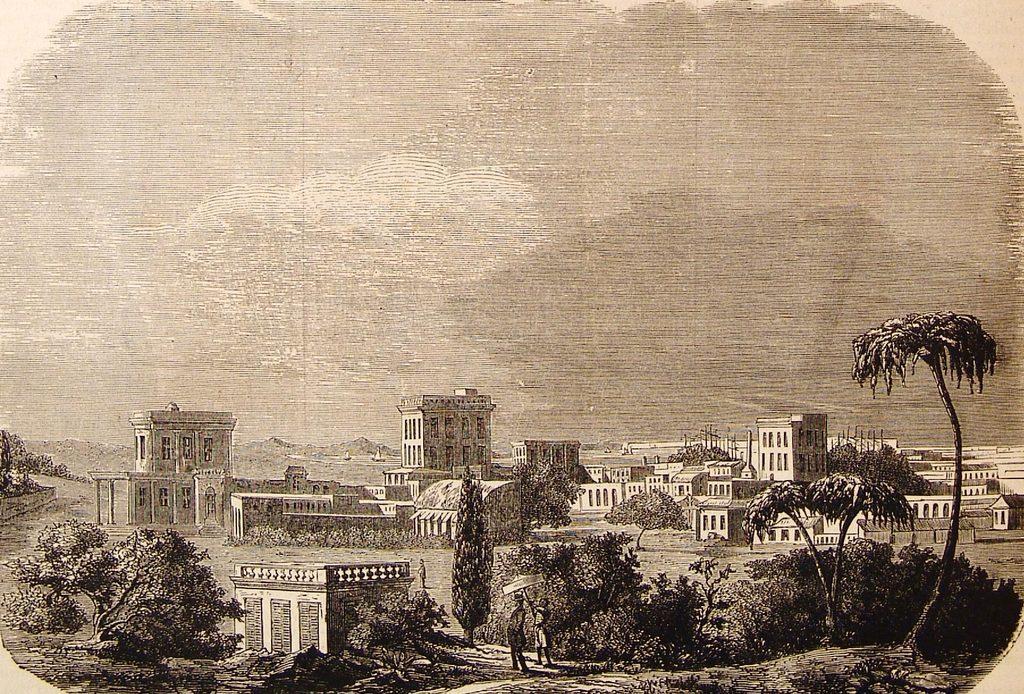Can you describe this image briefly? In this image I can see the trees. In the background, I can see the buildings and the sky. 